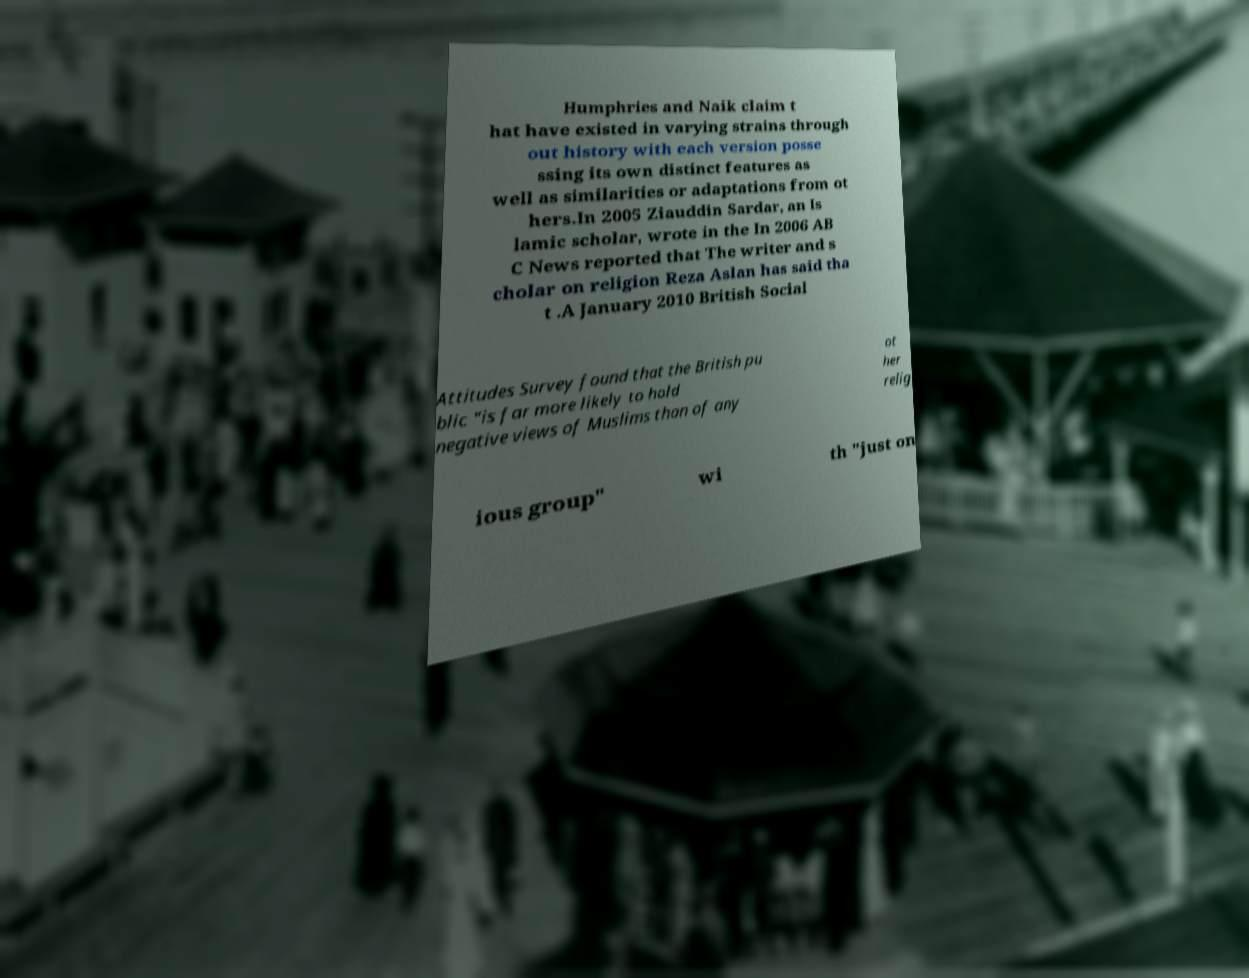For documentation purposes, I need the text within this image transcribed. Could you provide that? Humphries and Naik claim t hat have existed in varying strains through out history with each version posse ssing its own distinct features as well as similarities or adaptations from ot hers.In 2005 Ziauddin Sardar, an Is lamic scholar, wrote in the In 2006 AB C News reported that The writer and s cholar on religion Reza Aslan has said tha t .A January 2010 British Social Attitudes Survey found that the British pu blic "is far more likely to hold negative views of Muslims than of any ot her relig ious group" wi th "just on 